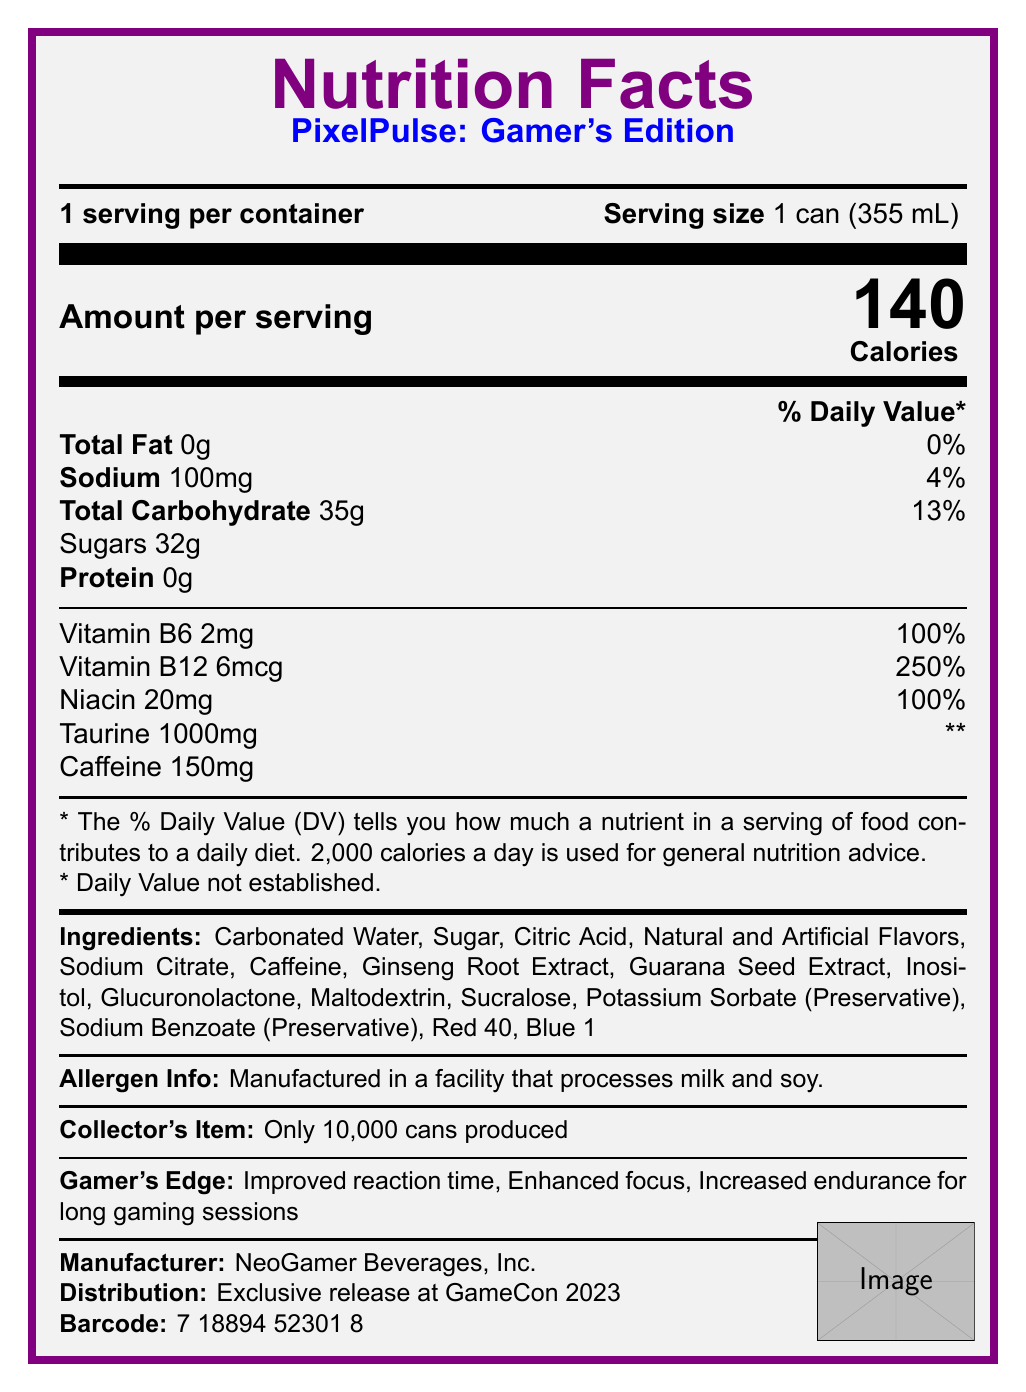what is the product name? The product name is clearly stated in the Nutrition Facts section under the title "PixelPulse: Gamer's Edition".
Answer: PixelPulse: Gamer's Edition what is the serving size of the energy drink? The serving size is provided as "1 can (355 mL)" in the document.
Answer: 1 can (355 mL) how much caffeine is in one serving of the drink? The document lists the caffeine content as 150mg under the nutrition information.
Answer: 150mg what are the allergen warnings for this product? The allergen information specifies that the product is manufactured in a facility that processes milk and soy.
Answer: Manufactured in a facility that processes milk and soy. how many calories are there per serving? The document indicates that each serving contains 140 calories.
Answer: 140 which vitamins are included in the nutrition information? A. Vitamin A and Vitamin C B. Vitamin D and Vitamin E C. Vitamin B6 and Vitamin B12 D. Vitamin K and Niacin The nutrition information includes Vitamin B6, Vitamin B12, and Niacin.
Answer: C how much sugar is in one can of this energy drink? The sugar content is indicated as 32g under total carbohydrates in the nutrition information.
Answer: 32g what is the percentage of daily value for Vitamin B12? A. 100% B. 150% C. 200% D. 250% The daily value for Vitamin B12 is listed as 250% in the nutrition information.
Answer: D is the energy drink produced in limited volumes? (Yes/No) The label mentions that this is a collector's item with only 10,000 cans produced.
Answer: Yes describe the main idea of the document The document includes comprehensive details about PixelPulse: Gamer's Edition, highlighting nutritional content, special features for gamers, and its status as a limited-edition collectible.
Answer: The document provides the nutrition facts and other relevant information about a limited-edition energy drink named "PixelPulse: Gamer's Edition." It includes details such as serving size, calorie content, ingredient list, allergen information, and vitamins and minerals provided. The drink is specially designed for gamers with features like improved reaction time and focus, showcasing pixelated graphics elements. The product is a limited release by NeoGamer Beverages, Inc., exclusively available at GameCon 2023. what is the total fat content in this drink? The nutrition information shows a total fat content of 0g.
Answer: 0g what company manufactures this energy drink? The document states that the manufacturer is NeoGamer Beverages, Inc.
Answer: NeoGamer Beverages, Inc. what special releases or exclusivity information is provided? The document mentions that the energy drink is an exclusive release at GameCon 2023.
Answer: Exclusive release at GameCon 2023 what kind of preservatives are listed in the ingredients? The preservatives listed in the ingredients are Potassium Sorbate and Sodium Benzoate.
Answer: Potassium Sorbate and Sodium Benzoate why is taurine included in the list of vitamins and minerals without a daily value percentage? Taurine is marked with "**" indicating that its daily value has not been established, as noted in the document.
Answer: Daily Value not established list two pixelated graphics elements featured on the can The document mentions several pixelated graphics elements, including an 8-bit style logo and retro game character icons.
Answer: 8-bit style logo, Retro game character icons how much sodium is in the energy drink? The nutritional information lists the sodium content as 100mg.
Answer: 100mg who is the target audience for this energy drink? The product is specially designed for gamers, featuring enhancements for improved reaction time and focus during long gaming sessions.
Answer: Gamers what is the barcode on the can? The barcode listed in the document is 7 18894 52301 8.
Answer: 7 18894 52301 8 does this drink contain gluten? The document does not provide specific information about gluten content.
Answer: Not enough information 